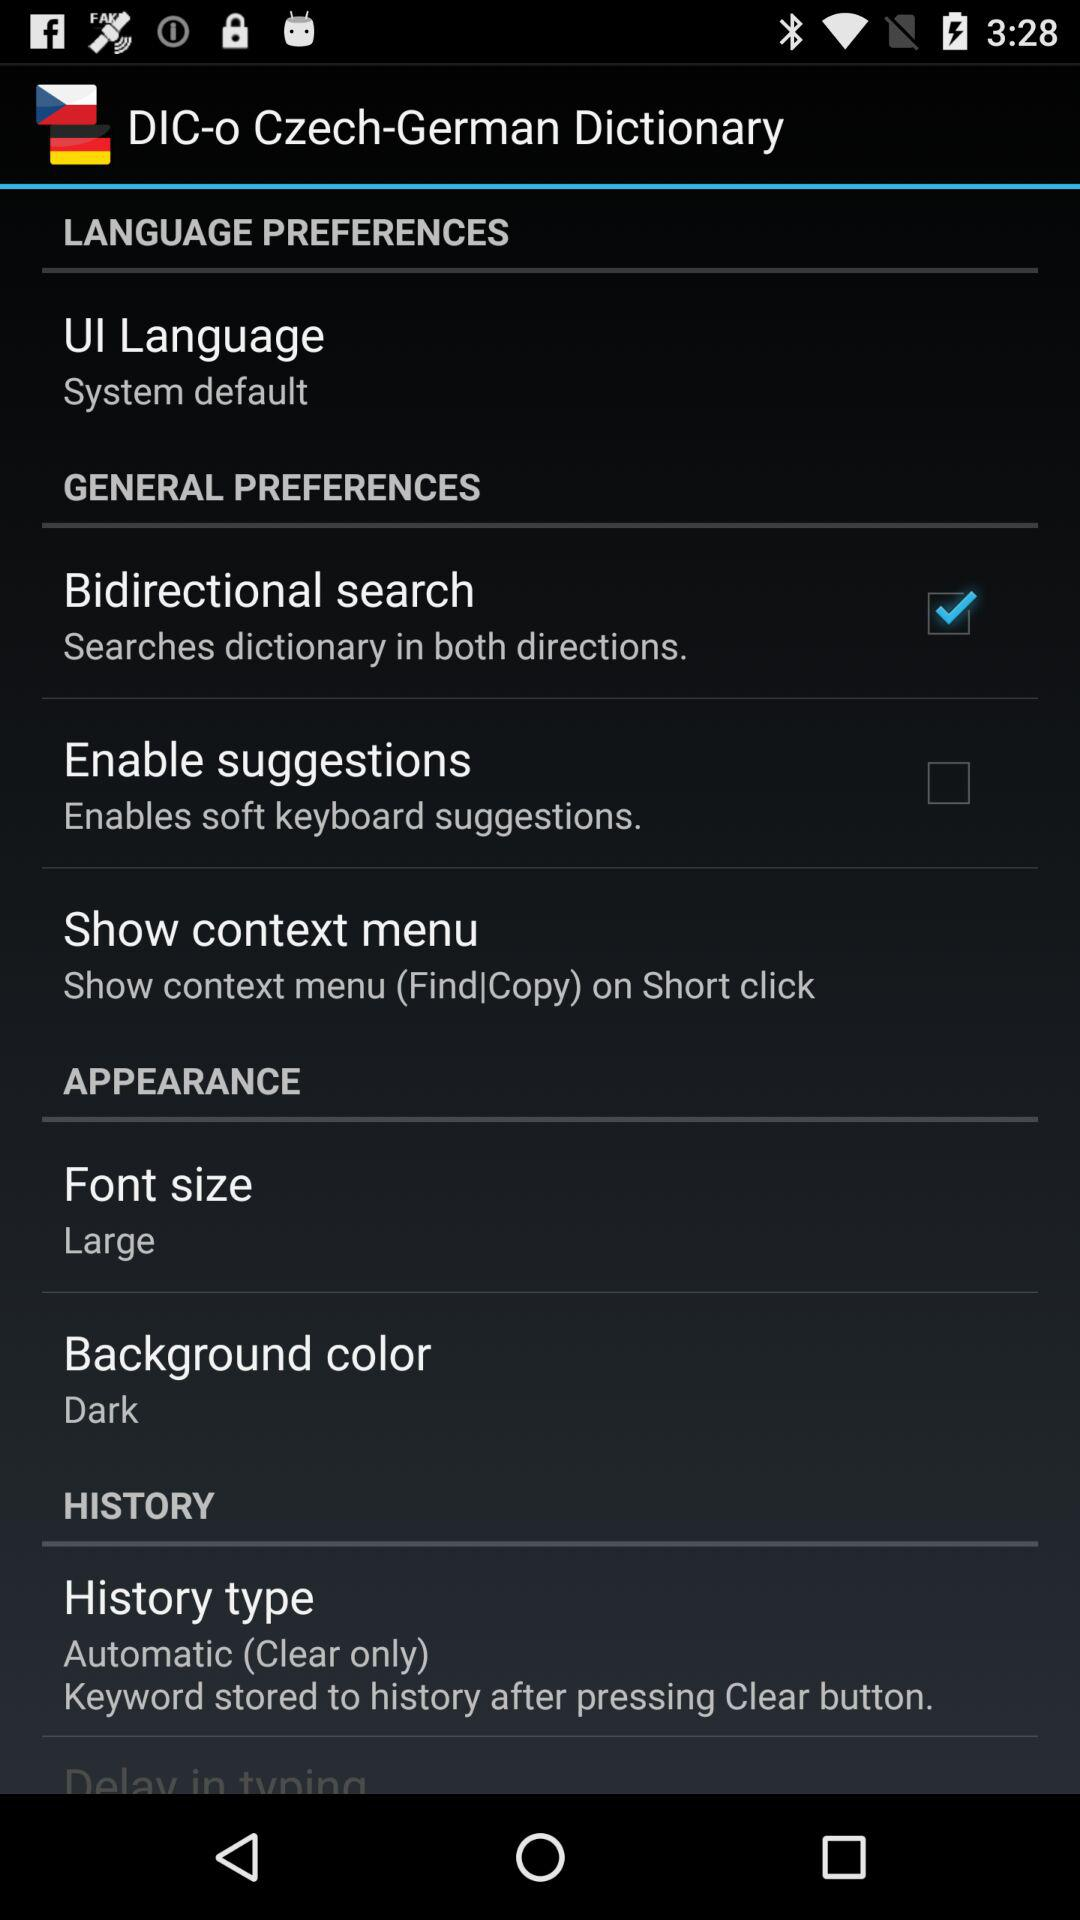What is the selected background color? The selected background color is dark. 